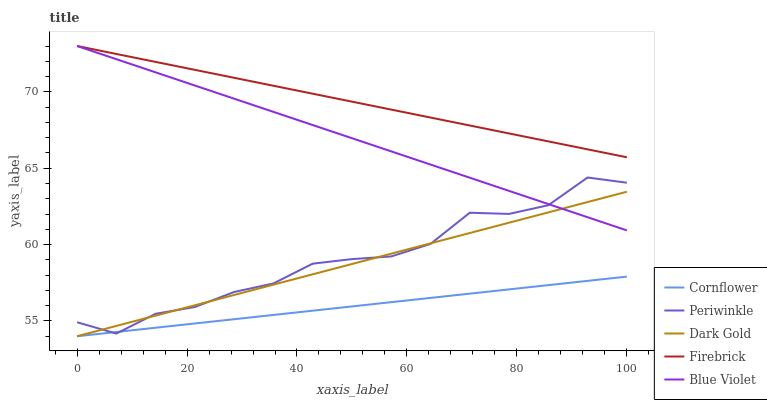Does Cornflower have the minimum area under the curve?
Answer yes or no. Yes. Does Firebrick have the maximum area under the curve?
Answer yes or no. Yes. Does Periwinkle have the minimum area under the curve?
Answer yes or no. No. Does Periwinkle have the maximum area under the curve?
Answer yes or no. No. Is Cornflower the smoothest?
Answer yes or no. Yes. Is Periwinkle the roughest?
Answer yes or no. Yes. Is Firebrick the smoothest?
Answer yes or no. No. Is Firebrick the roughest?
Answer yes or no. No. Does Periwinkle have the lowest value?
Answer yes or no. No. Does Blue Violet have the highest value?
Answer yes or no. Yes. Does Periwinkle have the highest value?
Answer yes or no. No. Is Cornflower less than Firebrick?
Answer yes or no. Yes. Is Firebrick greater than Dark Gold?
Answer yes or no. Yes. Does Cornflower intersect Firebrick?
Answer yes or no. No. 